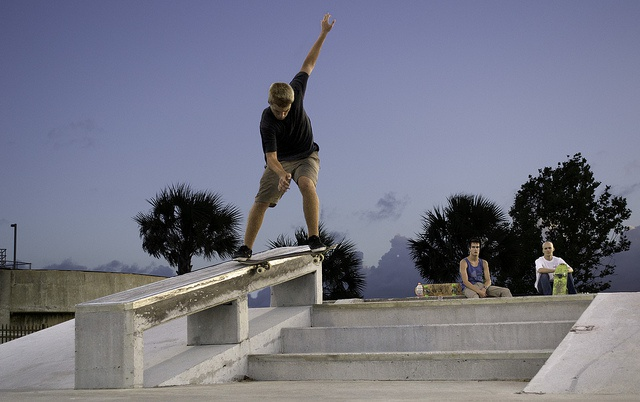Describe the objects in this image and their specific colors. I can see people in blue, black, maroon, and gray tones, people in blue, gray, black, and tan tones, people in blue, black, darkgray, lightgray, and gray tones, skateboard in blue, darkgray, black, gray, and lightgray tones, and skateboard in blue, olive, darkgreen, and black tones in this image. 